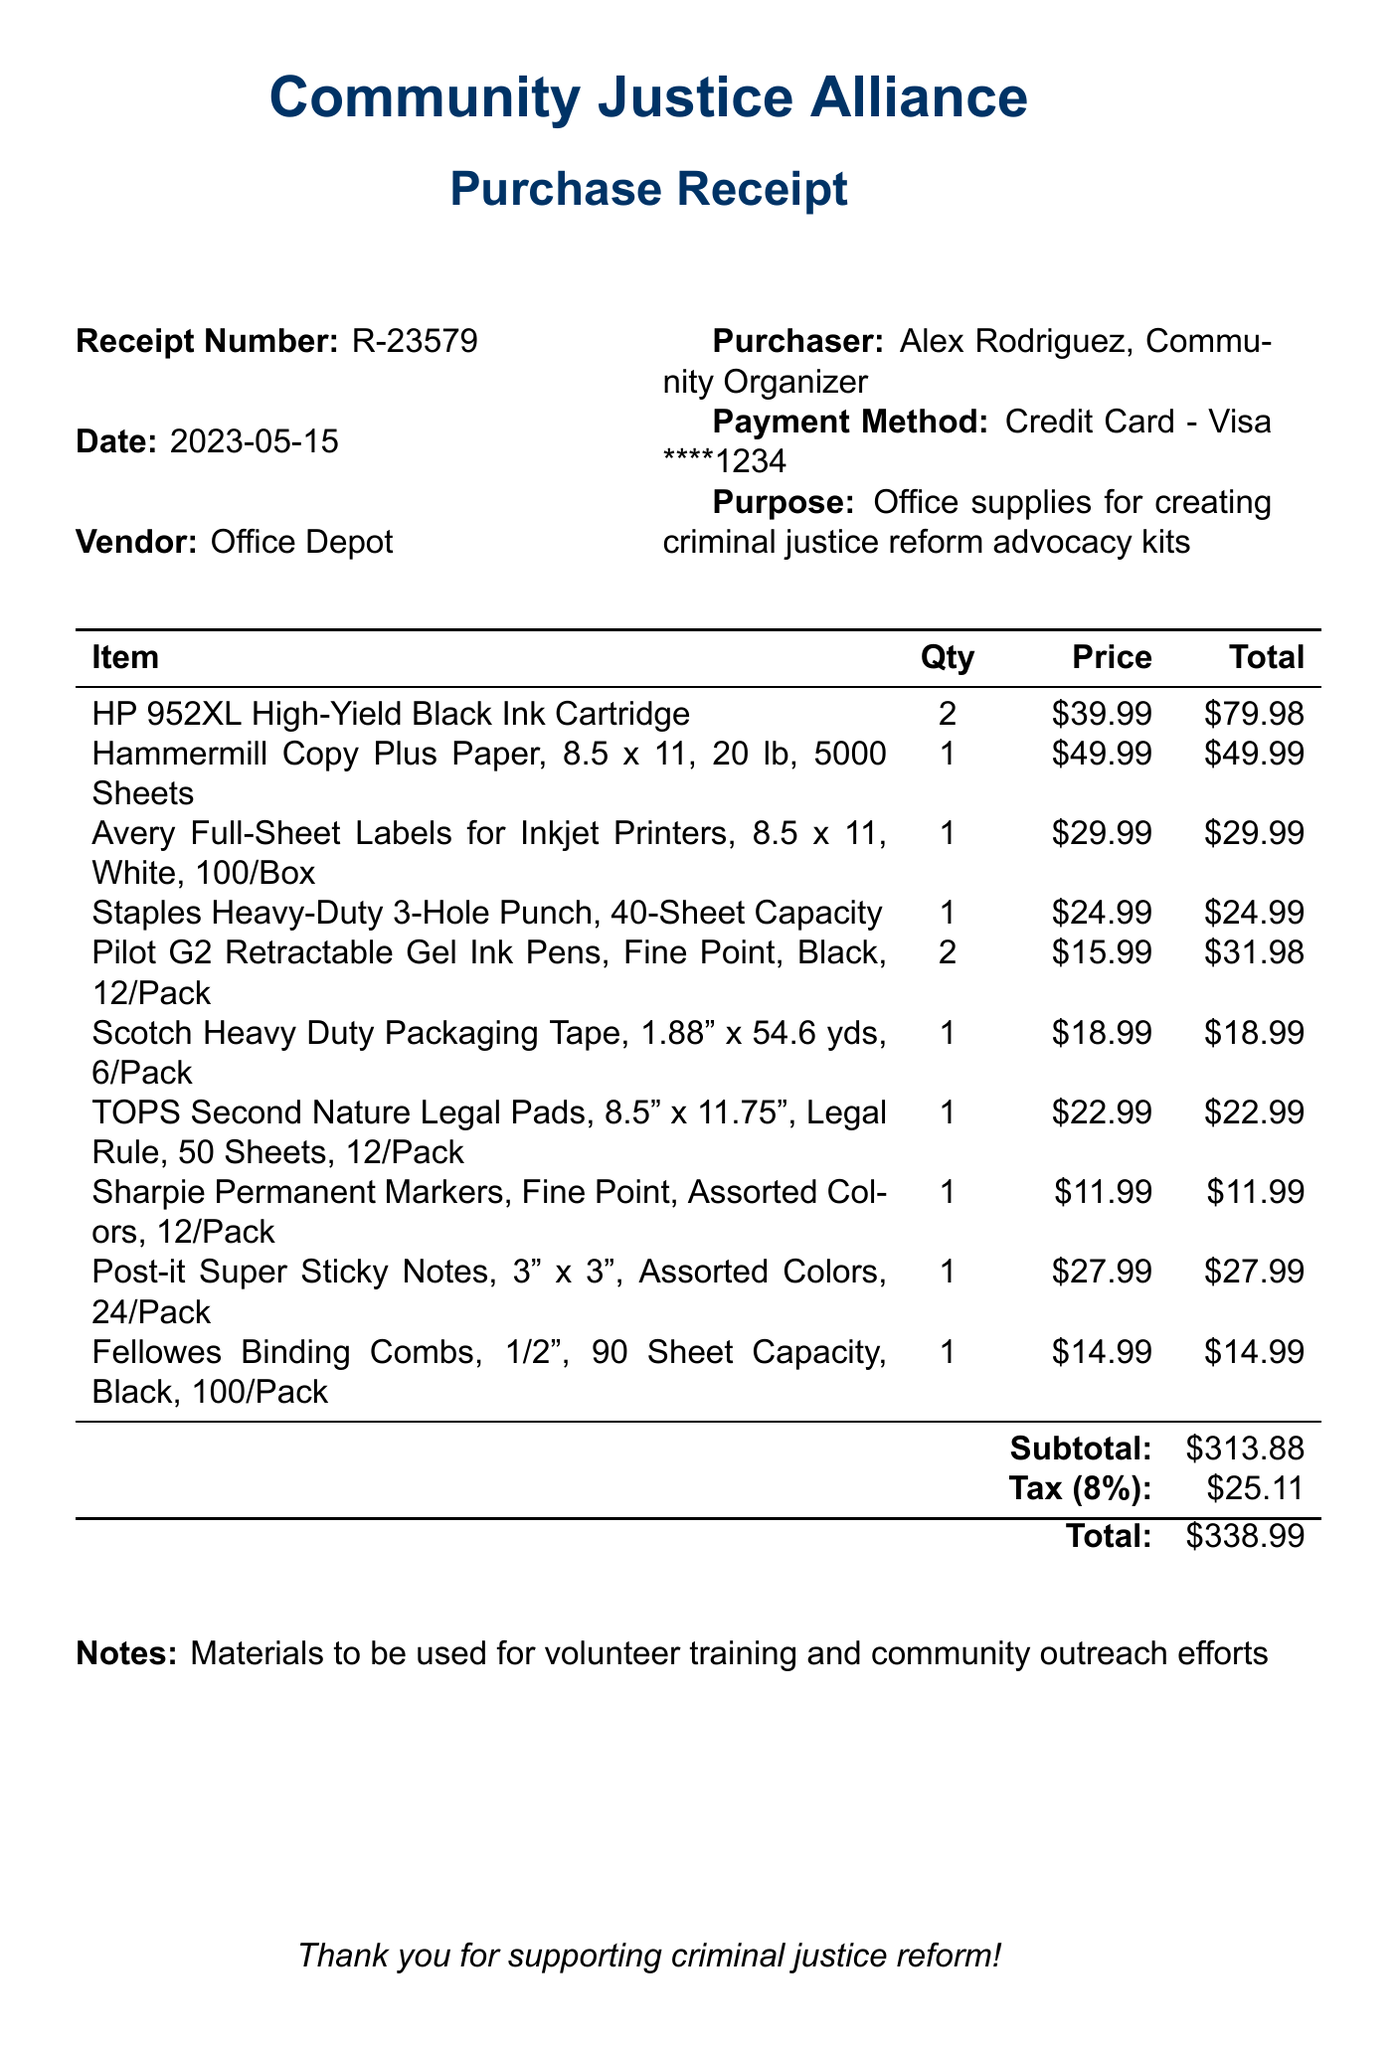What is the receipt number? The receipt number is provided in the document for tracking purposes and is labeled clearly.
Answer: R-23579 What is the date of the purchase? The date indicates when the purchase occurred and is directly stated on the receipt.
Answer: 2023-05-15 Who is the purchaser? The purchaser's name is mentioned along with their role in the organization, highlighting accountability.
Answer: Alex Rodriguez, Community Organizer What is the total amount spent on the purchase? The total amount is calculated at the end of the receipt, including the subtotal and tax.
Answer: 338.99 What is the purpose of this purchase? The purpose specifies why the supplies were acquired and supports the organization's mission.
Answer: Office supplies for creating criminal justice reform advocacy kits How many types of items were purchased? This reflects the variety of items on the receipt, requiring counting the distinct items listed.
Answer: 10 What payment method was used? The payment method is noted to indicate how the transaction was completed.
Answer: Credit Card - Visa ****1234 What is the tax amount applied? The document includes a tax calculation, which is an essential part of the total.
Answer: 25.11 What type of items were included in the purchase? The items listed provide insight about their function in the context of the organization’s activities.
Answer: Office supplies 